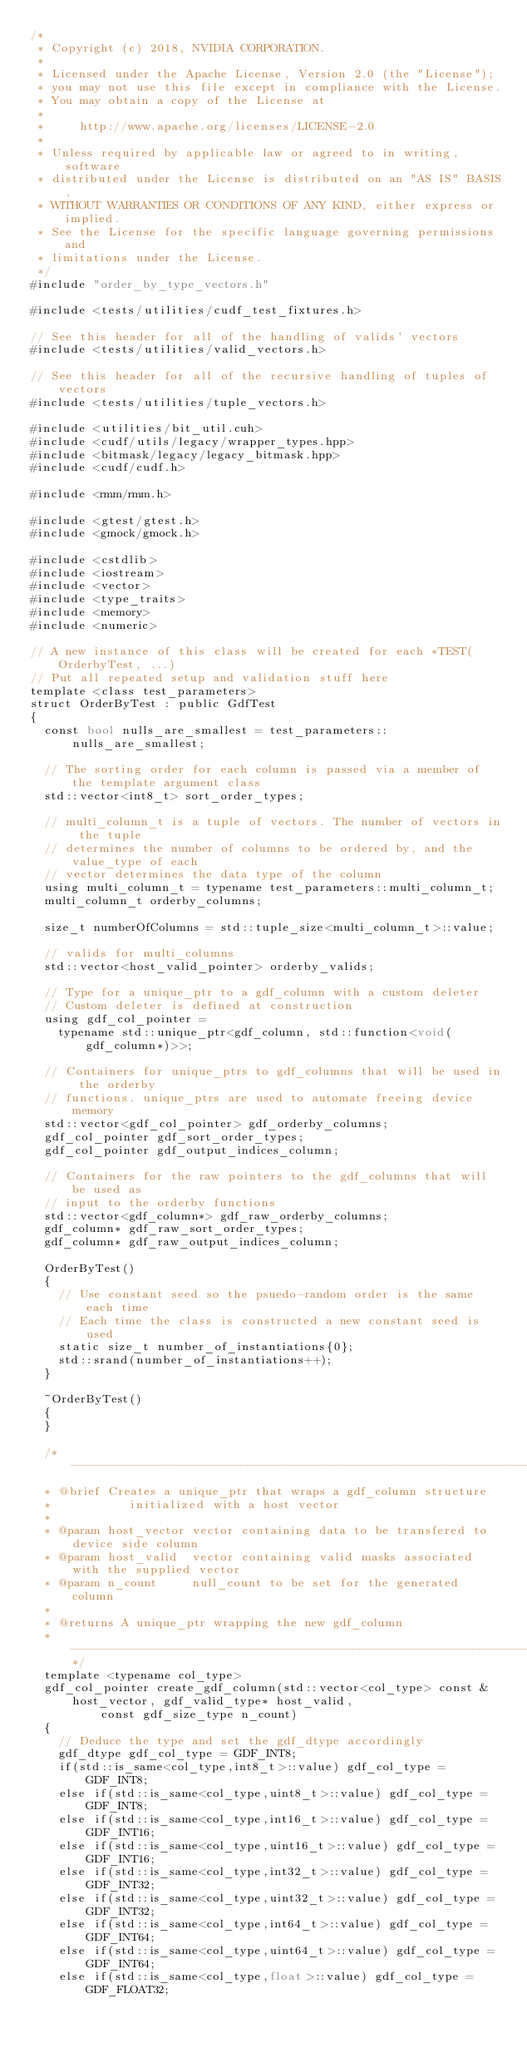<code> <loc_0><loc_0><loc_500><loc_500><_Cuda_>/*
 * Copyright (c) 2018, NVIDIA CORPORATION.
 *
 * Licensed under the Apache License, Version 2.0 (the "License");
 * you may not use this file except in compliance with the License.
 * You may obtain a copy of the License at
 *
 *     http://www.apache.org/licenses/LICENSE-2.0
 *
 * Unless required by applicable law or agreed to in writing, software
 * distributed under the License is distributed on an "AS IS" BASIS,
 * WITHOUT WARRANTIES OR CONDITIONS OF ANY KIND, either express or implied.
 * See the License for the specific language governing permissions and
 * limitations under the License.
 */
#include "order_by_type_vectors.h"

#include <tests/utilities/cudf_test_fixtures.h>

// See this header for all of the handling of valids' vectors
#include <tests/utilities/valid_vectors.h>

// See this header for all of the recursive handling of tuples of vectors
#include <tests/utilities/tuple_vectors.h>

#include <utilities/bit_util.cuh>
#include <cudf/utils/legacy/wrapper_types.hpp>
#include <bitmask/legacy/legacy_bitmask.hpp>
#include <cudf/cudf.h>

#include <rmm/rmm.h>

#include <gtest/gtest.h>
#include <gmock/gmock.h>

#include <cstdlib>
#include <iostream>
#include <vector>
#include <type_traits>
#include <memory>
#include <numeric>

// A new instance of this class will be created for each *TEST(OrderbyTest, ...)
// Put all repeated setup and validation stuff here
template <class test_parameters>
struct OrderByTest : public GdfTest
{
  const bool nulls_are_smallest = test_parameters::nulls_are_smallest;

  // The sorting order for each column is passed via a member of the template argument class
  std::vector<int8_t> sort_order_types;

  // multi_column_t is a tuple of vectors. The number of vectors in the tuple
  // determines the number of columns to be ordered by, and the value_type of each
  // vector determines the data type of the column
  using multi_column_t = typename test_parameters::multi_column_t;
  multi_column_t orderby_columns;

  size_t numberOfColumns = std::tuple_size<multi_column_t>::value;

  // valids for multi_columns
  std::vector<host_valid_pointer> orderby_valids;

  // Type for a unique_ptr to a gdf_column with a custom deleter
  // Custom deleter is defined at construction
  using gdf_col_pointer =
    typename std::unique_ptr<gdf_column, std::function<void(gdf_column*)>>;

  // Containers for unique_ptrs to gdf_columns that will be used in the orderby
  // functions. unique_ptrs are used to automate freeing device memory
  std::vector<gdf_col_pointer> gdf_orderby_columns;
  gdf_col_pointer gdf_sort_order_types;
  gdf_col_pointer gdf_output_indices_column;

  // Containers for the raw pointers to the gdf_columns that will be used as
  // input to the orderby functions
  std::vector<gdf_column*> gdf_raw_orderby_columns;
  gdf_column* gdf_raw_sort_order_types;
  gdf_column* gdf_raw_output_indices_column;

  OrderByTest()
  {
    // Use constant seed so the psuedo-random order is the same each time
    // Each time the class is constructed a new constant seed is used
    static size_t number_of_instantiations{0};
    std::srand(number_of_instantiations++);
  }

  ~OrderByTest()
  {
  }

  /* --------------------------------------------------------------------------*
  * @brief Creates a unique_ptr that wraps a gdf_column structure 
  *           initialized with a host vector
  *
  * @param host_vector vector containing data to be transfered to device side column
  * @param host_valid  vector containing valid masks associated with the supplied vector
  * @param n_count     null_count to be set for the generated column
  *
  * @returns A unique_ptr wrapping the new gdf_column
  * --------------------------------------------------------------------------*/
  template <typename col_type>
  gdf_col_pointer create_gdf_column(std::vector<col_type> const & host_vector, gdf_valid_type* host_valid,
          const gdf_size_type n_count)
  {
    // Deduce the type and set the gdf_dtype accordingly
    gdf_dtype gdf_col_type = GDF_INT8;
    if(std::is_same<col_type,int8_t>::value) gdf_col_type = GDF_INT8;
    else if(std::is_same<col_type,uint8_t>::value) gdf_col_type = GDF_INT8;
    else if(std::is_same<col_type,int16_t>::value) gdf_col_type = GDF_INT16;
    else if(std::is_same<col_type,uint16_t>::value) gdf_col_type = GDF_INT16;
    else if(std::is_same<col_type,int32_t>::value) gdf_col_type = GDF_INT32;
    else if(std::is_same<col_type,uint32_t>::value) gdf_col_type = GDF_INT32;
    else if(std::is_same<col_type,int64_t>::value) gdf_col_type = GDF_INT64;
    else if(std::is_same<col_type,uint64_t>::value) gdf_col_type = GDF_INT64;
    else if(std::is_same<col_type,float>::value) gdf_col_type = GDF_FLOAT32;</code> 